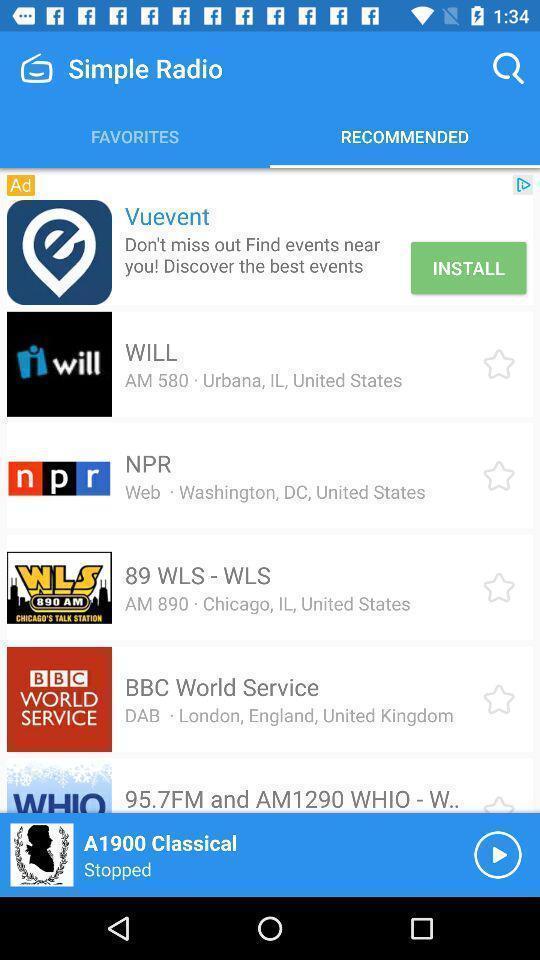What can you discern from this picture? Page displaying recommended radio stations. 